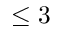Convert formula to latex. <formula><loc_0><loc_0><loc_500><loc_500>\leq 3</formula> 